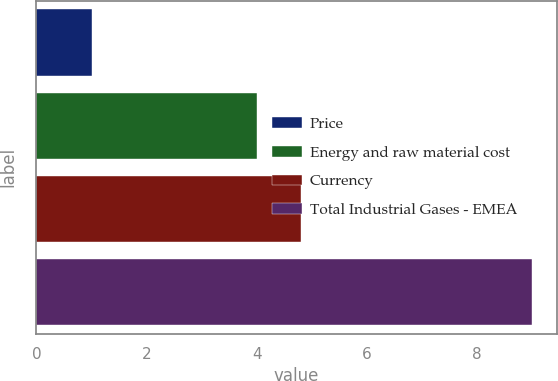<chart> <loc_0><loc_0><loc_500><loc_500><bar_chart><fcel>Price<fcel>Energy and raw material cost<fcel>Currency<fcel>Total Industrial Gases - EMEA<nl><fcel>1<fcel>4<fcel>4.8<fcel>9<nl></chart> 